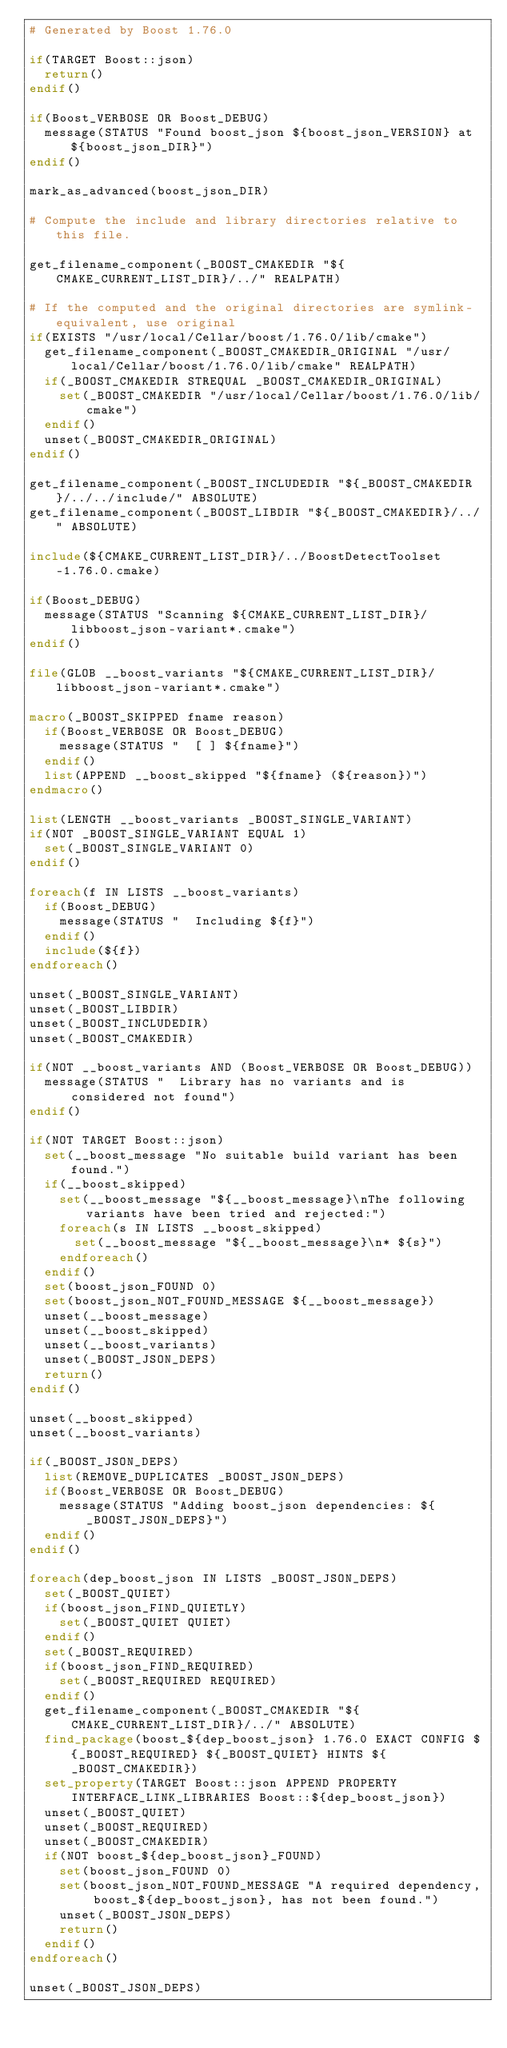Convert code to text. <code><loc_0><loc_0><loc_500><loc_500><_CMake_># Generated by Boost 1.76.0

if(TARGET Boost::json)
  return()
endif()

if(Boost_VERBOSE OR Boost_DEBUG)
  message(STATUS "Found boost_json ${boost_json_VERSION} at ${boost_json_DIR}")
endif()

mark_as_advanced(boost_json_DIR)

# Compute the include and library directories relative to this file.

get_filename_component(_BOOST_CMAKEDIR "${CMAKE_CURRENT_LIST_DIR}/../" REALPATH)

# If the computed and the original directories are symlink-equivalent, use original
if(EXISTS "/usr/local/Cellar/boost/1.76.0/lib/cmake")
  get_filename_component(_BOOST_CMAKEDIR_ORIGINAL "/usr/local/Cellar/boost/1.76.0/lib/cmake" REALPATH)
  if(_BOOST_CMAKEDIR STREQUAL _BOOST_CMAKEDIR_ORIGINAL)
    set(_BOOST_CMAKEDIR "/usr/local/Cellar/boost/1.76.0/lib/cmake")
  endif()
  unset(_BOOST_CMAKEDIR_ORIGINAL)
endif()

get_filename_component(_BOOST_INCLUDEDIR "${_BOOST_CMAKEDIR}/../../include/" ABSOLUTE)
get_filename_component(_BOOST_LIBDIR "${_BOOST_CMAKEDIR}/../" ABSOLUTE)

include(${CMAKE_CURRENT_LIST_DIR}/../BoostDetectToolset-1.76.0.cmake)

if(Boost_DEBUG)
  message(STATUS "Scanning ${CMAKE_CURRENT_LIST_DIR}/libboost_json-variant*.cmake")
endif()

file(GLOB __boost_variants "${CMAKE_CURRENT_LIST_DIR}/libboost_json-variant*.cmake")

macro(_BOOST_SKIPPED fname reason)
  if(Boost_VERBOSE OR Boost_DEBUG)
    message(STATUS "  [ ] ${fname}")
  endif()
  list(APPEND __boost_skipped "${fname} (${reason})")
endmacro()

list(LENGTH __boost_variants _BOOST_SINGLE_VARIANT)
if(NOT _BOOST_SINGLE_VARIANT EQUAL 1)
  set(_BOOST_SINGLE_VARIANT 0)
endif()

foreach(f IN LISTS __boost_variants)
  if(Boost_DEBUG)
    message(STATUS "  Including ${f}")
  endif()
  include(${f})
endforeach()

unset(_BOOST_SINGLE_VARIANT)
unset(_BOOST_LIBDIR)
unset(_BOOST_INCLUDEDIR)
unset(_BOOST_CMAKEDIR)

if(NOT __boost_variants AND (Boost_VERBOSE OR Boost_DEBUG))
  message(STATUS "  Library has no variants and is considered not found")
endif()

if(NOT TARGET Boost::json)
  set(__boost_message "No suitable build variant has been found.")
  if(__boost_skipped)
    set(__boost_message "${__boost_message}\nThe following variants have been tried and rejected:")
    foreach(s IN LISTS __boost_skipped)
      set(__boost_message "${__boost_message}\n* ${s}")
    endforeach()
  endif()
  set(boost_json_FOUND 0)
  set(boost_json_NOT_FOUND_MESSAGE ${__boost_message})
  unset(__boost_message)
  unset(__boost_skipped)
  unset(__boost_variants)
  unset(_BOOST_JSON_DEPS)
  return()
endif()

unset(__boost_skipped)
unset(__boost_variants)

if(_BOOST_JSON_DEPS)
  list(REMOVE_DUPLICATES _BOOST_JSON_DEPS)
  if(Boost_VERBOSE OR Boost_DEBUG)
    message(STATUS "Adding boost_json dependencies: ${_BOOST_JSON_DEPS}")
  endif()
endif()

foreach(dep_boost_json IN LISTS _BOOST_JSON_DEPS)
  set(_BOOST_QUIET)
  if(boost_json_FIND_QUIETLY)
    set(_BOOST_QUIET QUIET)
  endif()
  set(_BOOST_REQUIRED)
  if(boost_json_FIND_REQUIRED)
    set(_BOOST_REQUIRED REQUIRED)
  endif()
  get_filename_component(_BOOST_CMAKEDIR "${CMAKE_CURRENT_LIST_DIR}/../" ABSOLUTE)
  find_package(boost_${dep_boost_json} 1.76.0 EXACT CONFIG ${_BOOST_REQUIRED} ${_BOOST_QUIET} HINTS ${_BOOST_CMAKEDIR})
  set_property(TARGET Boost::json APPEND PROPERTY INTERFACE_LINK_LIBRARIES Boost::${dep_boost_json})
  unset(_BOOST_QUIET)
  unset(_BOOST_REQUIRED)
  unset(_BOOST_CMAKEDIR)
  if(NOT boost_${dep_boost_json}_FOUND)
    set(boost_json_FOUND 0)
    set(boost_json_NOT_FOUND_MESSAGE "A required dependency, boost_${dep_boost_json}, has not been found.")
    unset(_BOOST_JSON_DEPS)
    return()
  endif()
endforeach()

unset(_BOOST_JSON_DEPS)
</code> 